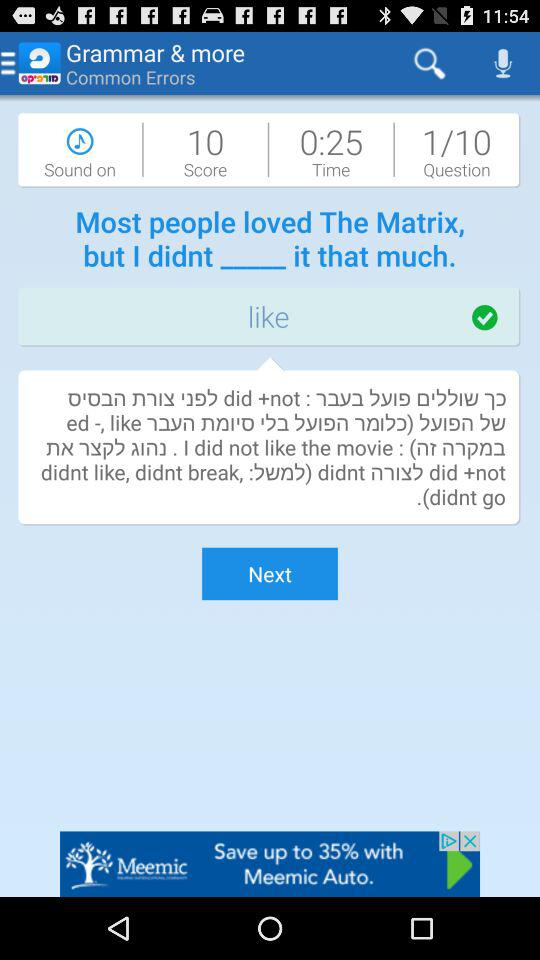Which question number am I at? You are at question number 1. 